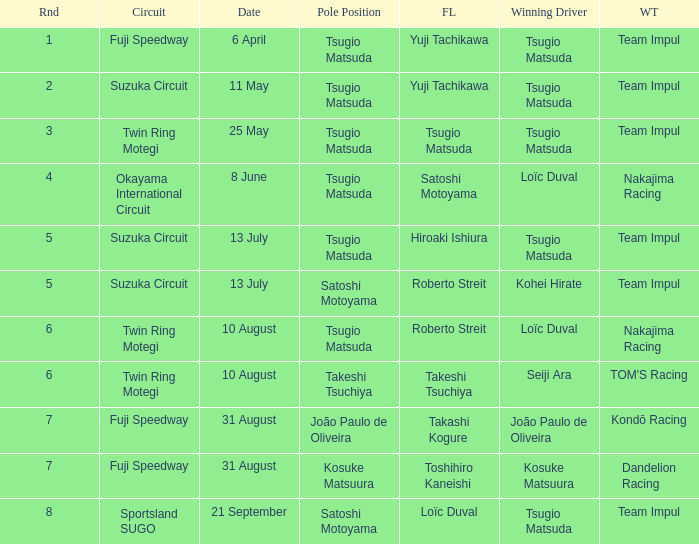What is the fastest lap for Seiji Ara? Takeshi Tsuchiya. 